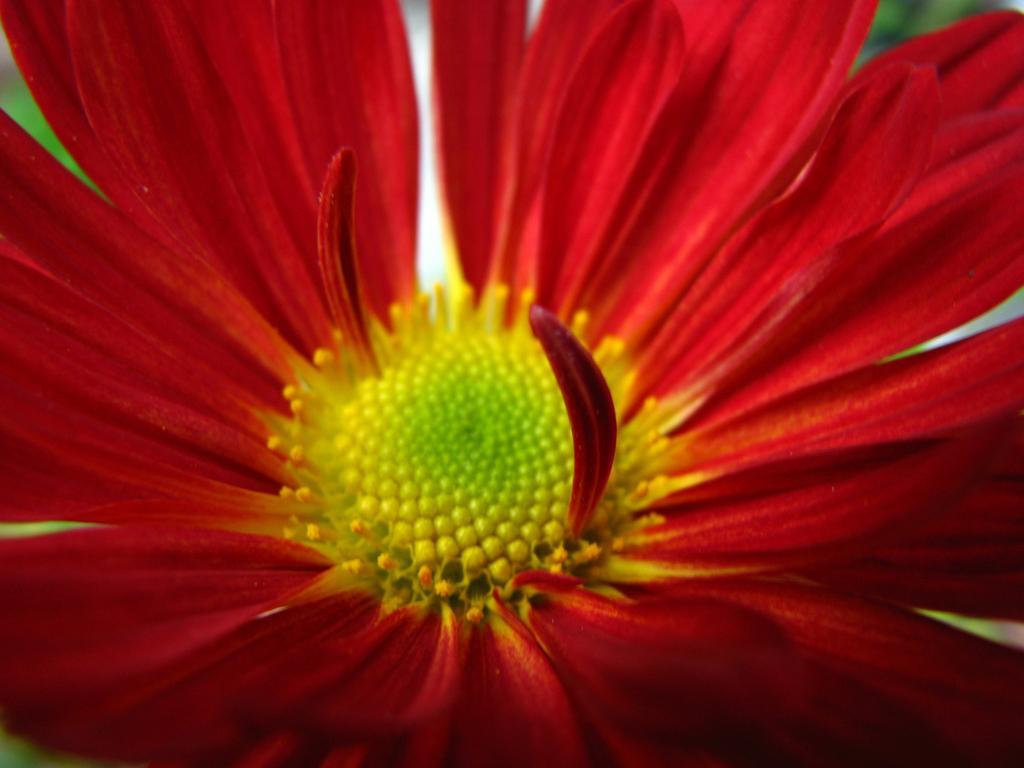How would you summarize this image in a sentence or two? The picture consists of a red color flower. In the background there is greenery. 